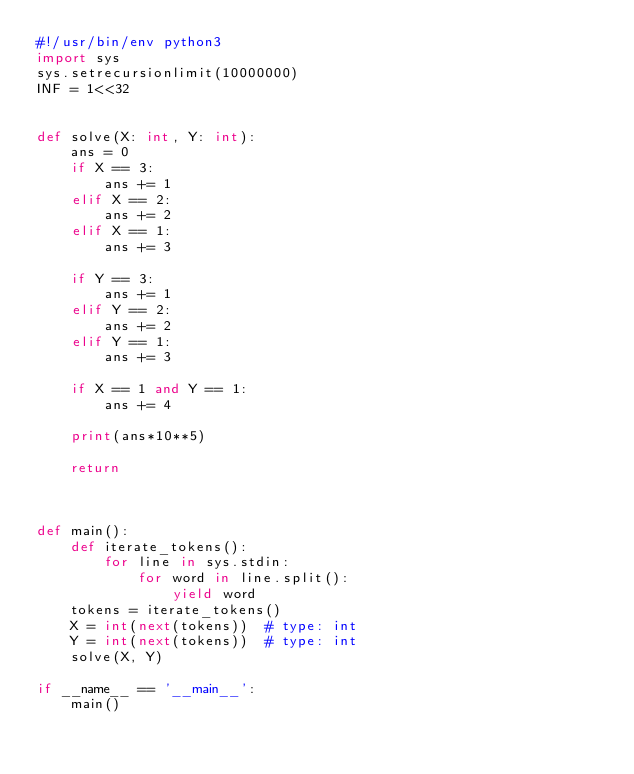<code> <loc_0><loc_0><loc_500><loc_500><_Python_>#!/usr/bin/env python3
import sys
sys.setrecursionlimit(10000000)
INF = 1<<32


def solve(X: int, Y: int):
    ans = 0
    if X == 3:
        ans += 1
    elif X == 2:
        ans += 2
    elif X == 1:
        ans += 3
    
    if Y == 3:
        ans += 1
    elif Y == 2:
        ans += 2
    elif Y == 1:
        ans += 3
    
    if X == 1 and Y == 1:
        ans += 4
    
    print(ans*10**5)

    return



def main():
    def iterate_tokens():
        for line in sys.stdin:
            for word in line.split():
                yield word
    tokens = iterate_tokens()
    X = int(next(tokens))  # type: int
    Y = int(next(tokens))  # type: int
    solve(X, Y)

if __name__ == '__main__':
    main()
</code> 